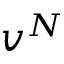<formula> <loc_0><loc_0><loc_500><loc_500>v ^ { N }</formula> 